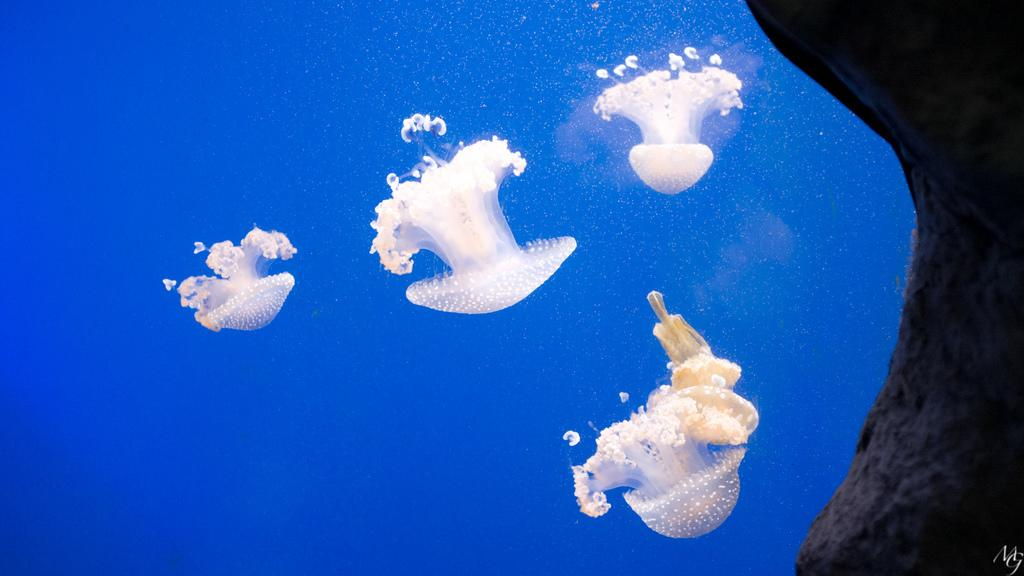How many jellyfishes are visible in the water in the image? There are 4 jellyfishes in the water in the image. What else can be seen on the right side of the image? There is a stone on the right side of the image. What type of lumber can be seen in the image? There is no lumber present in the image; it features jellyfishes in the water and a stone on the right side. How many sticks are visible in the image? There are no sticks visible in the image. 